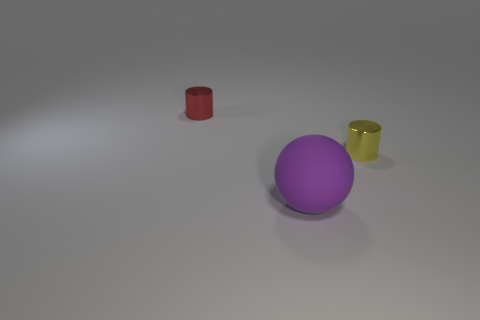What mood or atmosphere does the image evoke, and is there any significance to the color choices? The combination of a neutral background with the primary and secondary colors of the objects creates a minimalistic and clean atmosphere, potentially evoking a sense of order and simplicity. The color choices may be deliberate to contrast with each other effectively; red, yellow, and purple are spaced apart on the color wheel, providing a visually harmonious triad while also standing out individually due to their vividness against the muted background. 